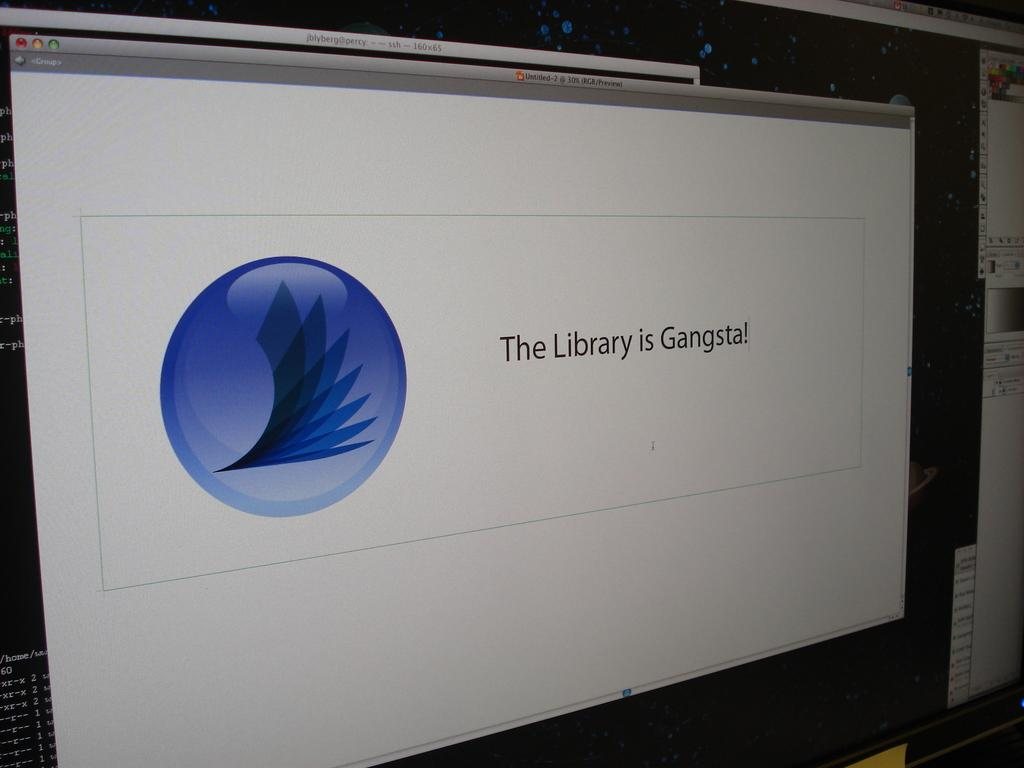<image>
Offer a succinct explanation of the picture presented. A computer display shows the message the library is gangsta. 